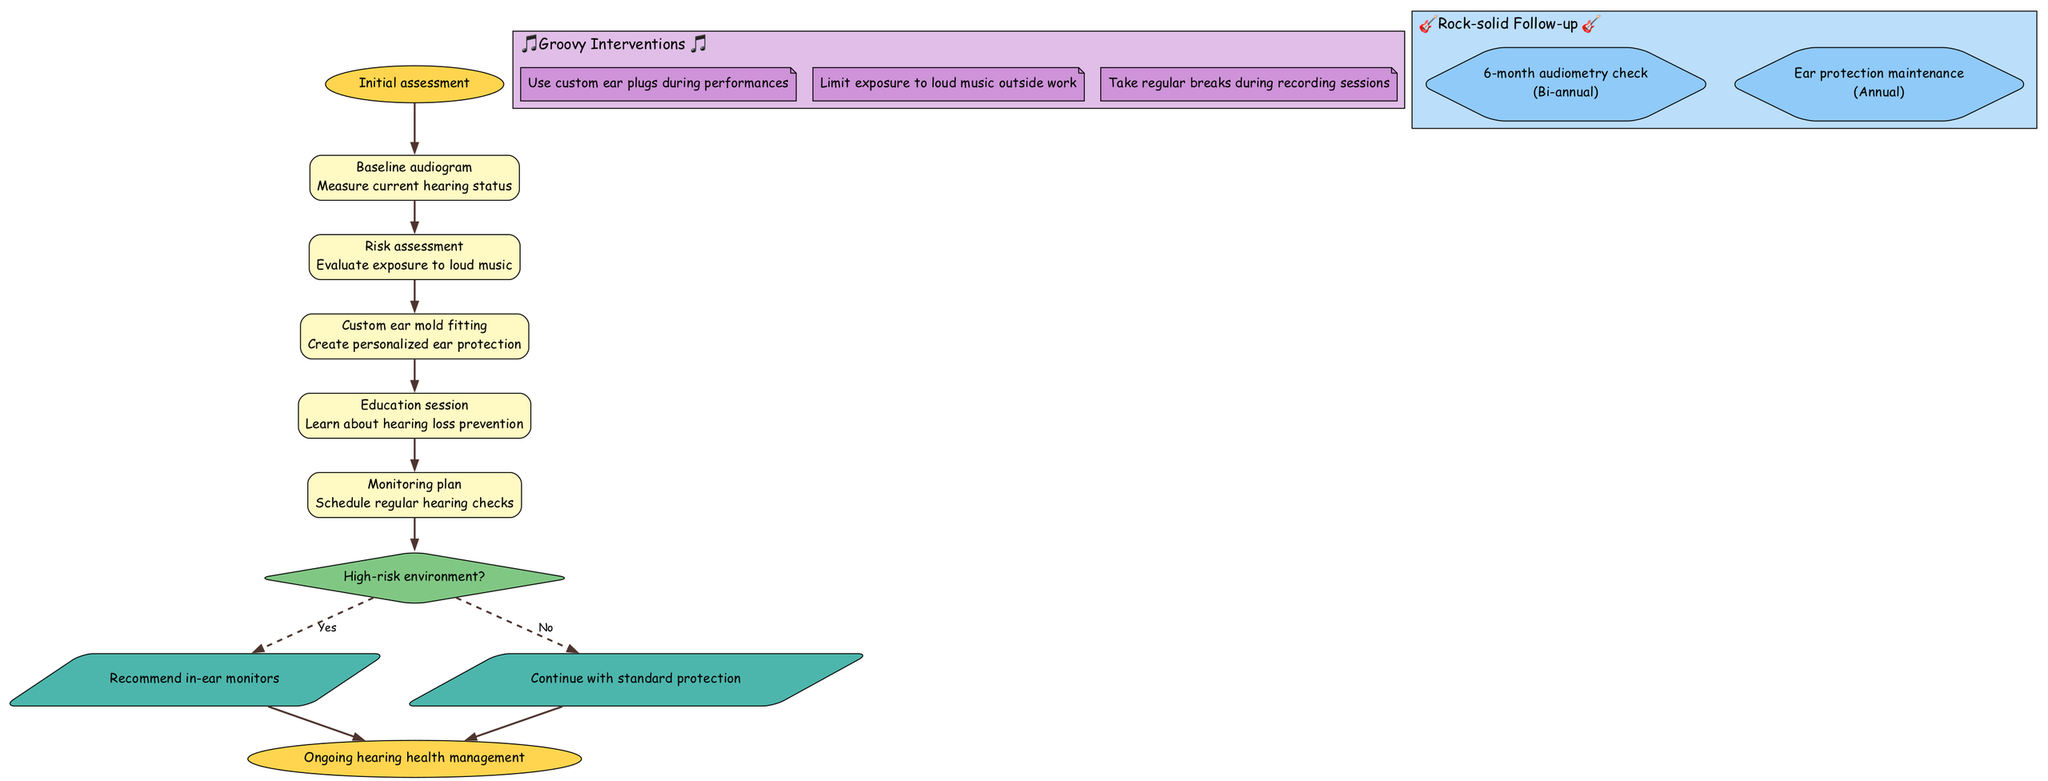What is the starting point of the clinical pathway? The starting point is explicitly labeled as "Initial assessment" in the diagram, indicating the beginning of the process for hearing loss prevention.
Answer: Initial assessment How many steps are in the clinical pathway? There are five steps listed sequentially in the pathway that detail the process steps for hearing loss prevention.
Answer: 5 What is the action taken after the baseline audiogram? The immediate action after the baseline audiogram is the "Risk assessment," which follows directly in the flow of the pathway.
Answer: Risk assessment What happens if a high-risk environment is identified? If a high-risk environment is identified, the action taken is to "Recommend in-ear monitors," as indicated in the decision node for this pathway.
Answer: Recommend in-ear monitors What are the follow-up actions mentioned in the pathway? The pathway outlines two follow-up actions: "6-month audiometry check (Bi-annual)" and "Ear protection maintenance (Annual)," both indicating ongoing care requirements.
Answer: 6-month audiometry check and Ear protection maintenance What type of node represents the decision-making point? The decision-making point in the diagram is represented as a diamond shape, which is a standard visualization for decision nodes in clinical pathways.
Answer: Diamond How often should audiometry checks be conducted? The diagram specifies that audiometry checks should be conducted bi-annually, making it a scheduled component of the follow-up actions.
Answer: Bi-annual Which intervention advises regarding exposure to loud music outside of work? The intervention that addresses exposure to loud music outside of work is explicitly stated as "Limit exposure to loud music outside work," indicating a clear guideline.
Answer: Limit exposure to loud music outside work What shape is used for the starting and ending nodes? Both the starting and ending nodes are represented as ovals in the diagram, visually highlighting the initiation and conclusion of the clinical pathway.
Answer: Oval 